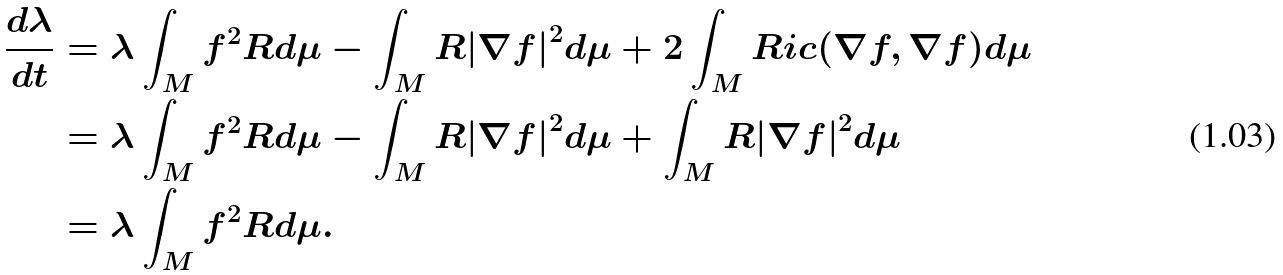<formula> <loc_0><loc_0><loc_500><loc_500>\frac { d \lambda } { d t } & = \lambda \int _ { M } f ^ { 2 } R d \mu - \int _ { M } R { \left | \nabla f \right | } ^ { 2 } d \mu + 2 \int _ { M } R i c ( \nabla f , \nabla f ) d \mu \\ & = \lambda \int _ { M } f ^ { 2 } R d \mu - \int _ { M } R { \left | \nabla f \right | } ^ { 2 } d \mu + \int _ { M } R { \left | \nabla f \right | } ^ { 2 } d \mu \\ & = \lambda \int _ { M } f ^ { 2 } R d \mu .</formula> 